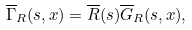<formula> <loc_0><loc_0><loc_500><loc_500>\overline { \Gamma } _ { R } ( s , x ) = \overline { R } ( s ) \overline { G } _ { R } ( s , x ) ,</formula> 